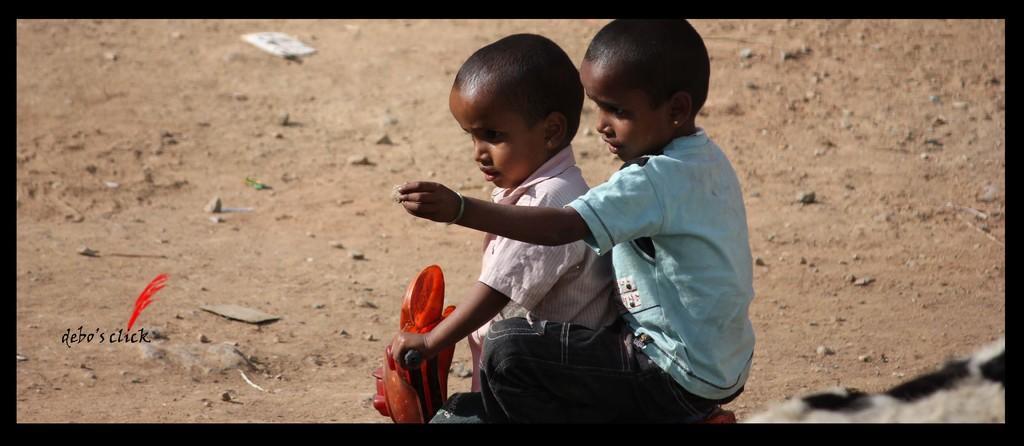How would you summarize this image in a sentence or two? In this image there is sand. There are stones. There are two kids sitting on a cycle. 